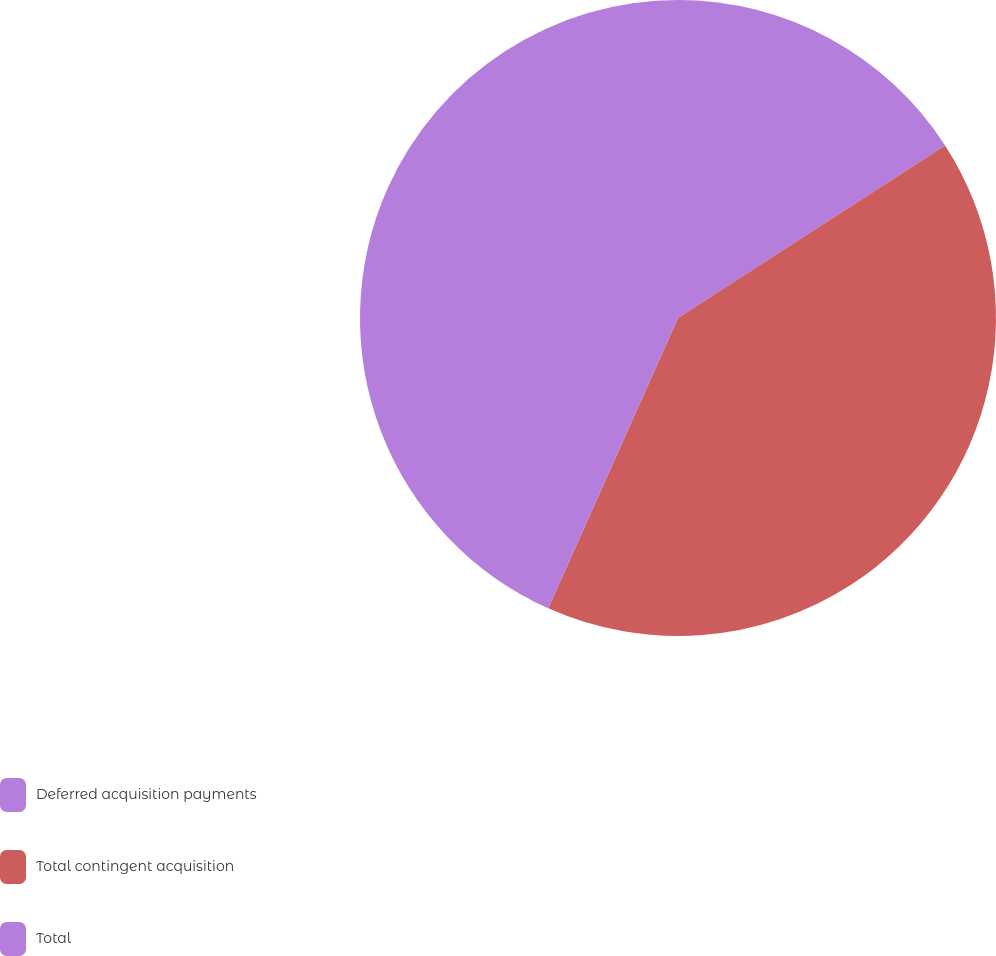Convert chart to OTSL. <chart><loc_0><loc_0><loc_500><loc_500><pie_chart><fcel>Deferred acquisition payments<fcel>Total contingent acquisition<fcel>Total<nl><fcel>15.87%<fcel>40.82%<fcel>43.31%<nl></chart> 